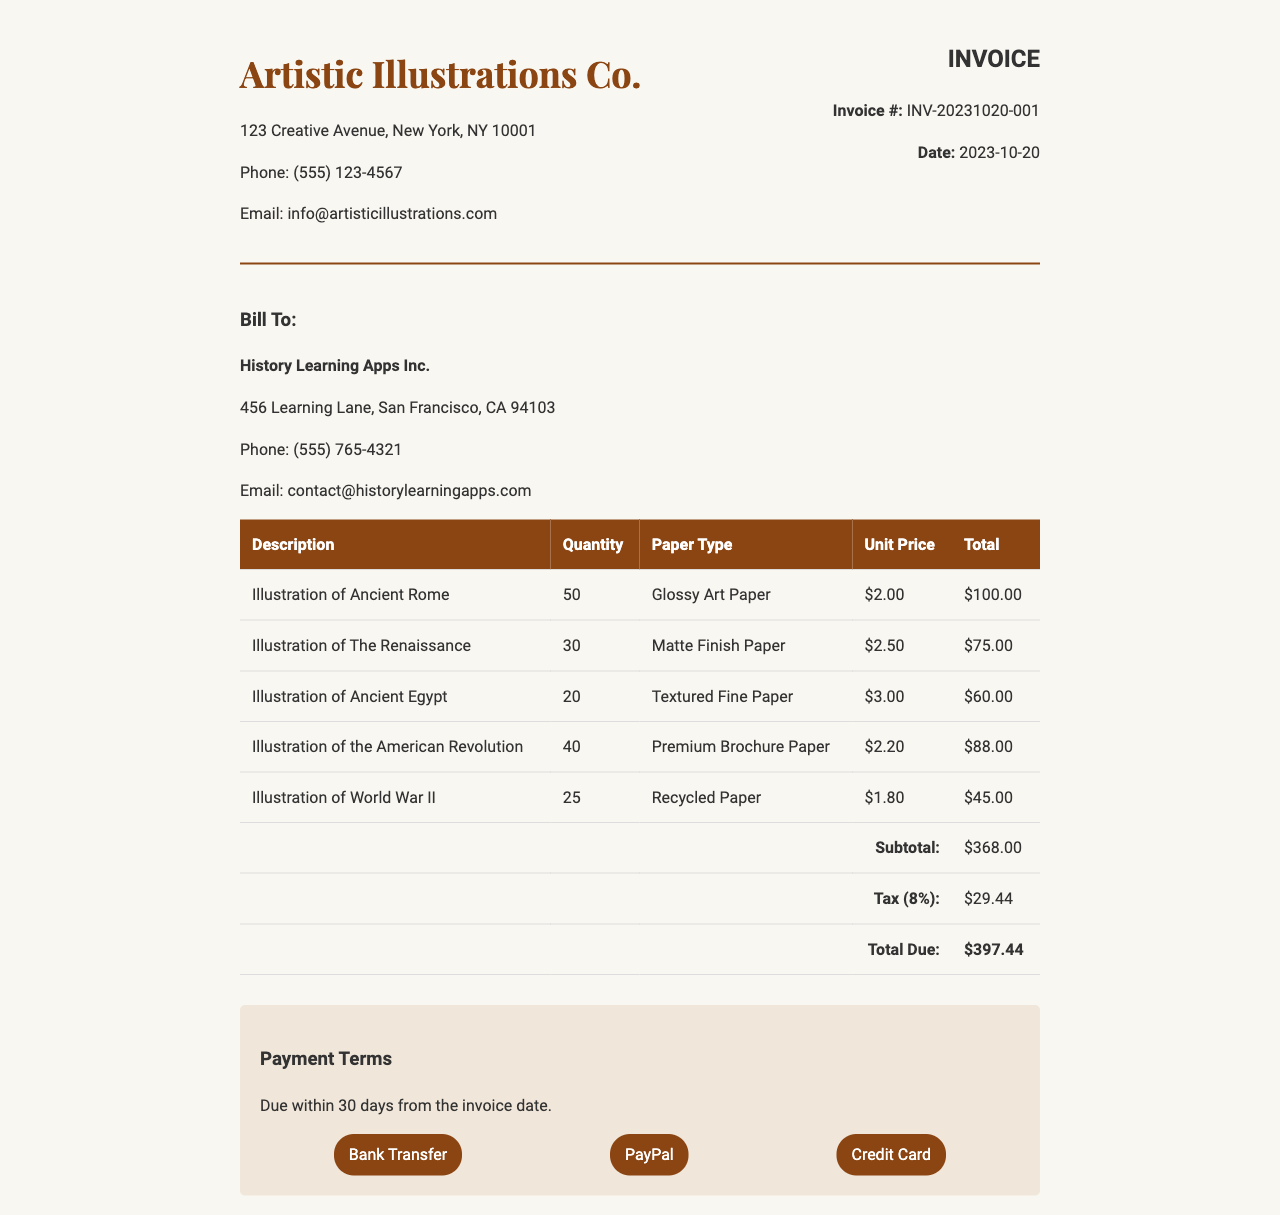What is the invoice number? The invoice number is provided in the document as a unique identifier for this transaction, which is typically formatted with the prefix "INV-", the date, and a sequence number.
Answer: INV-20231020-001 What is the total due amount? The total due amount is calculated by adding the subtotal and the tax, which results in the final amount owed.
Answer: $397.44 How many illustrations of Ancient Rome were printed? The quantity printed for the specific illustration is listed in the invoice under the respective description.
Answer: 50 What paper type was used for the illustrations of the Renaissance? The specific paper type for each illustration is detailed in the invoice, allowing for identification of the material used.
Answer: Matte Finish Paper What percentage is the tax applied to the subtotal? The document specifies that the tax is calculated as a percentage of the subtotal, which indicates the rate used for this calculation.
Answer: 8% What is the subtotal amount before tax? The subtotal amount sums up all individual totals for each item before applying tax, reflecting the total cost of services or goods provided.
Answer: $368.00 What date is the invoice dated? The invoice provides a specific date which represents when the transaction was formally recorded or created.
Answer: 2023-10-20 What are the payment methods accepted? The invoice outlines various payment methods available for settling the amount due, which indicates the options provided to the client.
Answer: Bank Transfer, PayPal, Credit Card How many quantities of illustrations of World War II were printed? The quantity printed is indicated next to the description of the illustration, representing the total number of copies requested.
Answer: 25 